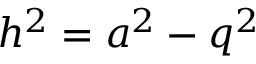Convert formula to latex. <formula><loc_0><loc_0><loc_500><loc_500>h ^ { 2 } = a ^ { 2 } - q ^ { 2 }</formula> 